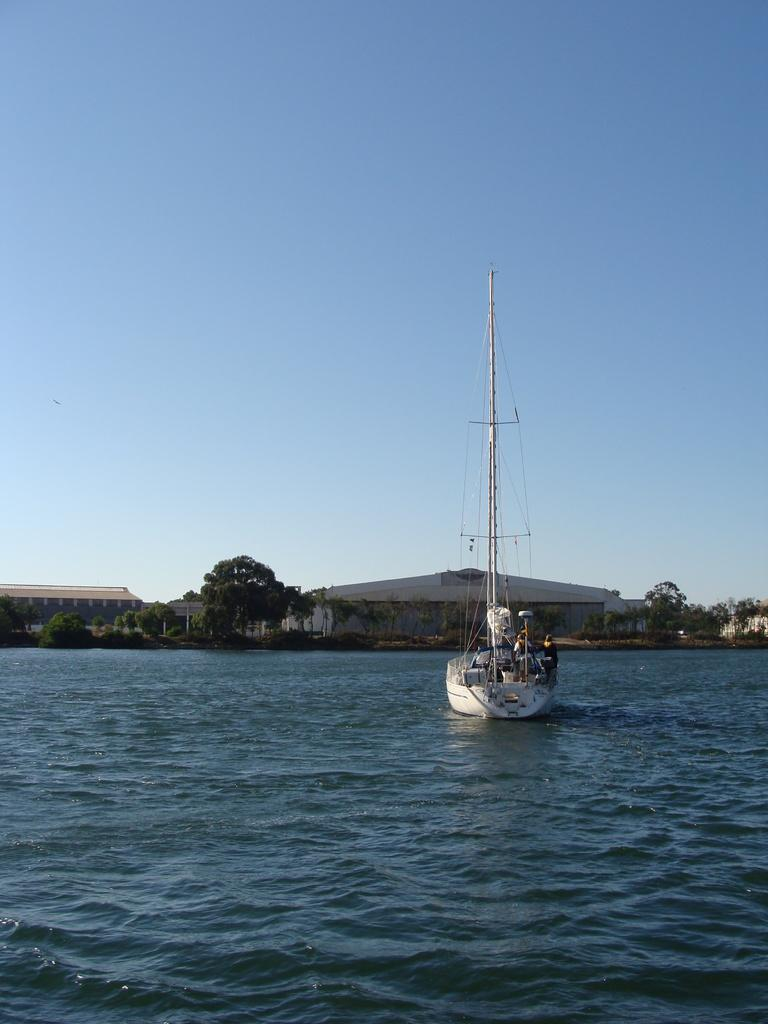What is the main subject of the image? The main subject of the image is a boat. Where is the boat located? The boat is on the sea. What can be seen in the background of the image? There are trees and buildings in the background of the image. What type of jeans is the boat wearing in the image? Boats do not wear jeans, as they are inanimate objects. 